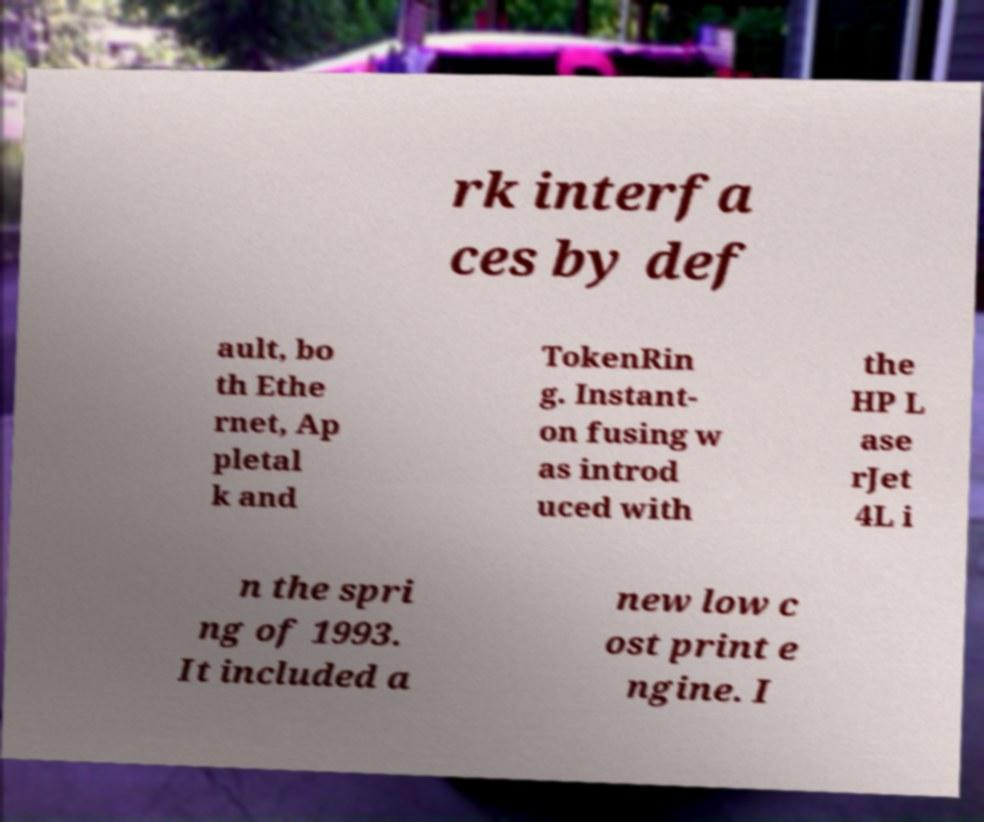There's text embedded in this image that I need extracted. Can you transcribe it verbatim? rk interfa ces by def ault, bo th Ethe rnet, Ap pletal k and TokenRin g. Instant- on fusing w as introd uced with the HP L ase rJet 4L i n the spri ng of 1993. It included a new low c ost print e ngine. I 